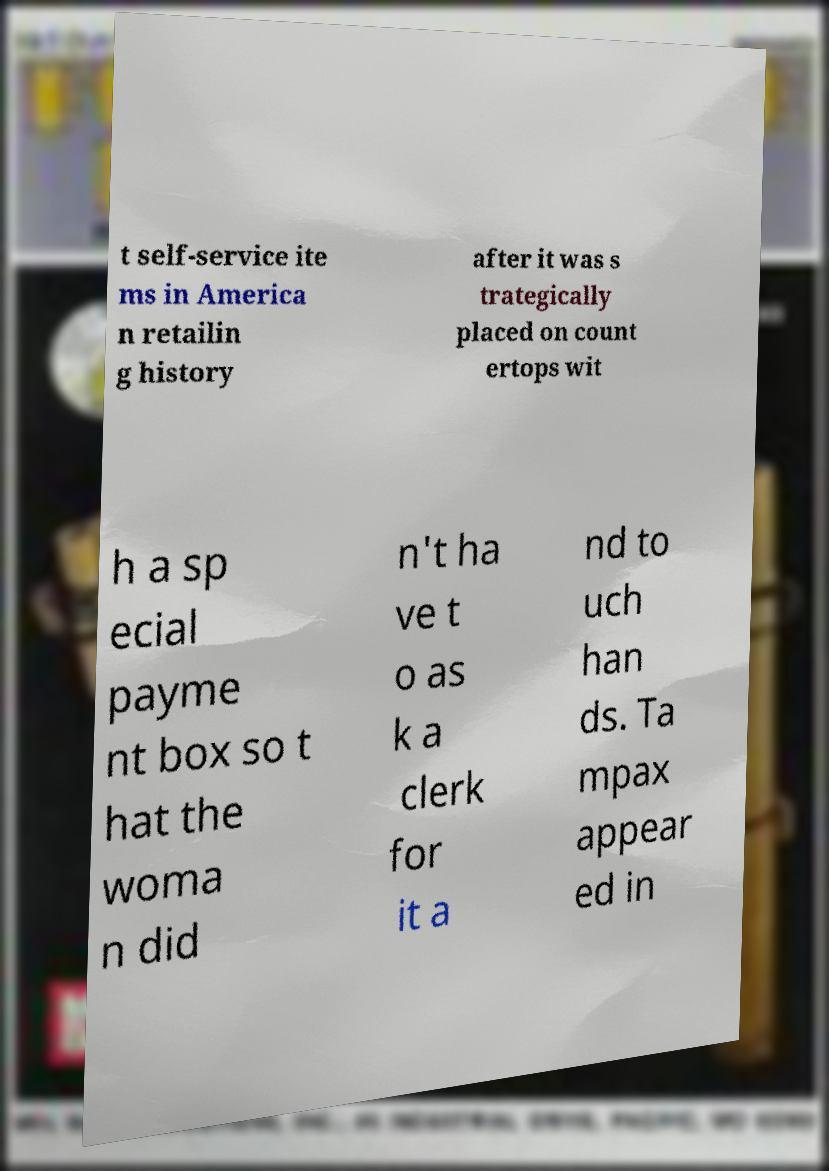I need the written content from this picture converted into text. Can you do that? t self-service ite ms in America n retailin g history after it was s trategically placed on count ertops wit h a sp ecial payme nt box so t hat the woma n did n't ha ve t o as k a clerk for it a nd to uch han ds. Ta mpax appear ed in 